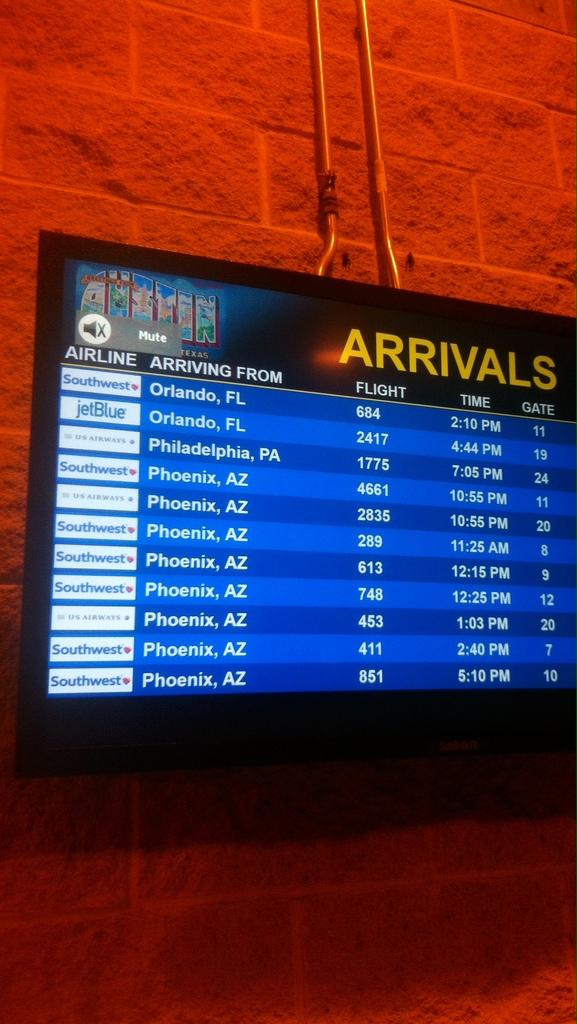Where is the arrivals from?
Your answer should be compact. Orlando. 